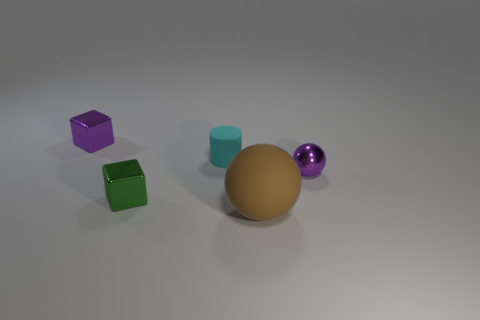Add 2 purple spheres. How many objects exist? 7 Subtract all spheres. How many objects are left? 3 Subtract all gray objects. Subtract all purple things. How many objects are left? 3 Add 2 purple things. How many purple things are left? 4 Add 3 large blue blocks. How many large blue blocks exist? 3 Subtract all purple blocks. How many blocks are left? 1 Subtract 1 purple cubes. How many objects are left? 4 Subtract all blue cubes. Subtract all blue cylinders. How many cubes are left? 2 Subtract all cyan cylinders. How many brown spheres are left? 1 